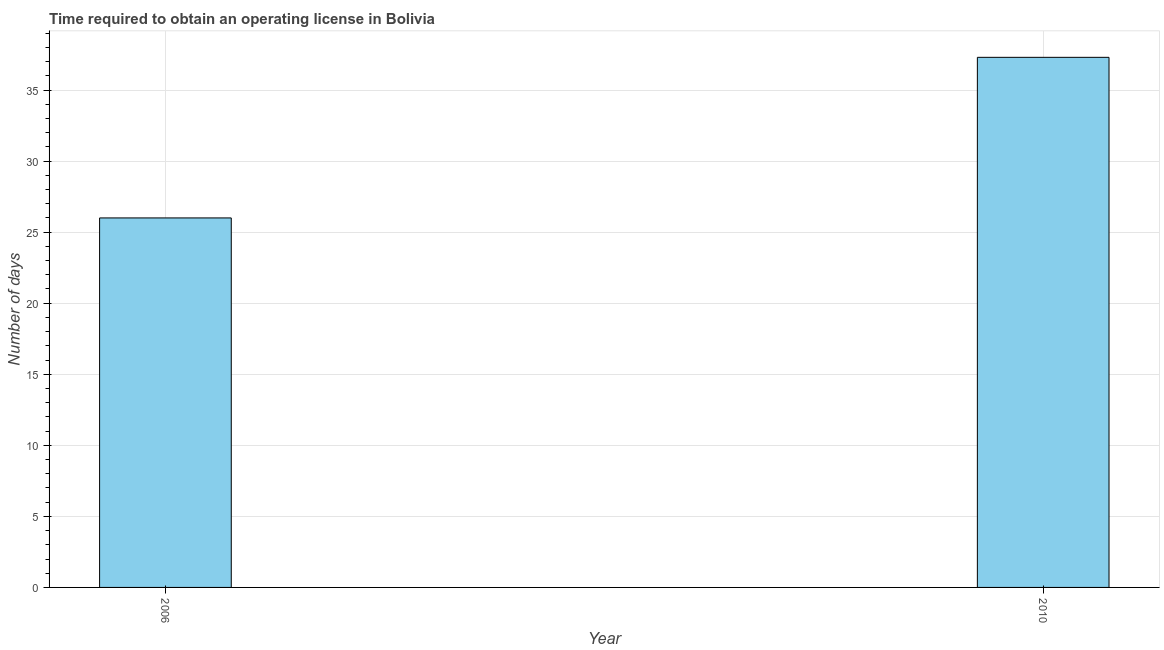Does the graph contain any zero values?
Offer a terse response. No. Does the graph contain grids?
Offer a very short reply. Yes. What is the title of the graph?
Ensure brevity in your answer.  Time required to obtain an operating license in Bolivia. What is the label or title of the Y-axis?
Keep it short and to the point. Number of days. What is the number of days to obtain operating license in 2010?
Keep it short and to the point. 37.3. Across all years, what is the maximum number of days to obtain operating license?
Provide a succinct answer. 37.3. Across all years, what is the minimum number of days to obtain operating license?
Provide a succinct answer. 26. In which year was the number of days to obtain operating license minimum?
Your answer should be compact. 2006. What is the sum of the number of days to obtain operating license?
Provide a short and direct response. 63.3. What is the average number of days to obtain operating license per year?
Give a very brief answer. 31.65. What is the median number of days to obtain operating license?
Offer a very short reply. 31.65. In how many years, is the number of days to obtain operating license greater than 17 days?
Ensure brevity in your answer.  2. Do a majority of the years between 2006 and 2010 (inclusive) have number of days to obtain operating license greater than 5 days?
Your answer should be compact. Yes. What is the ratio of the number of days to obtain operating license in 2006 to that in 2010?
Give a very brief answer. 0.7. In how many years, is the number of days to obtain operating license greater than the average number of days to obtain operating license taken over all years?
Offer a very short reply. 1. How many years are there in the graph?
Your answer should be compact. 2. What is the difference between two consecutive major ticks on the Y-axis?
Offer a very short reply. 5. What is the Number of days in 2006?
Ensure brevity in your answer.  26. What is the Number of days of 2010?
Ensure brevity in your answer.  37.3. What is the ratio of the Number of days in 2006 to that in 2010?
Your response must be concise. 0.7. 